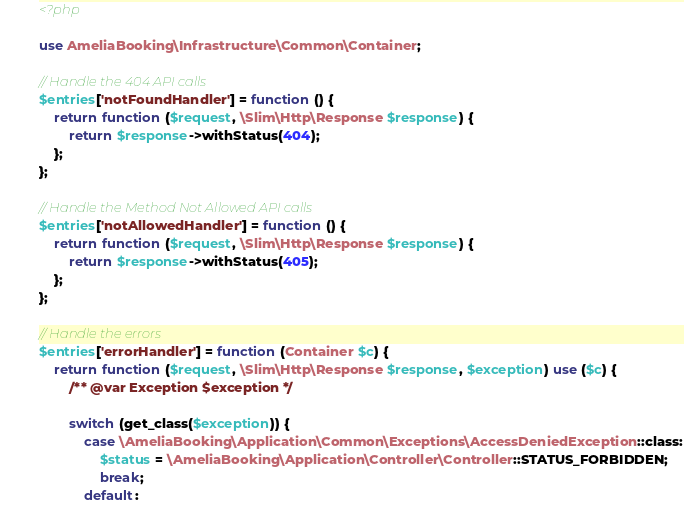<code> <loc_0><loc_0><loc_500><loc_500><_PHP_><?php

use AmeliaBooking\Infrastructure\Common\Container;

// Handle the 404 API calls
$entries['notFoundHandler'] = function () {
    return function ($request, \Slim\Http\Response $response) {
        return $response->withStatus(404);
    };
};

// Handle the Method Not Allowed API calls
$entries['notAllowedHandler'] = function () {
    return function ($request, \Slim\Http\Response $response) {
        return $response->withStatus(405);
    };
};

// Handle the errors
$entries['errorHandler'] = function (Container $c) {
    return function ($request, \Slim\Http\Response $response, $exception) use ($c) {
        /** @var Exception $exception */

        switch (get_class($exception)) {
            case \AmeliaBooking\Application\Common\Exceptions\AccessDeniedException::class:
                $status = \AmeliaBooking\Application\Controller\Controller::STATUS_FORBIDDEN;
                break;
            default:</code> 